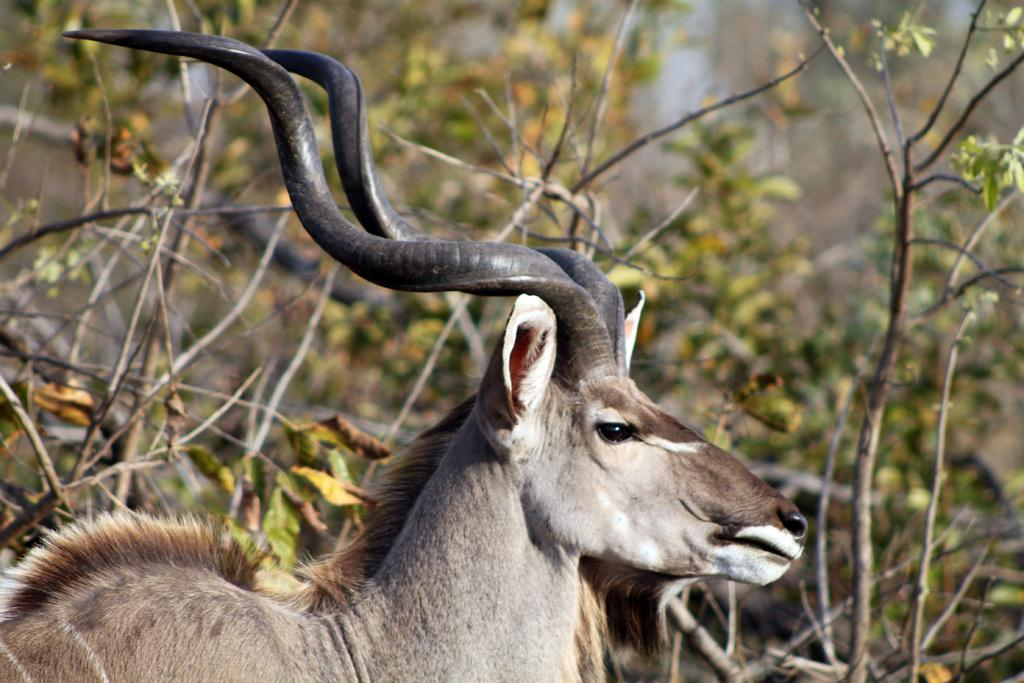What type of animal can be seen in the image? There is an animal in the image, but its specific type cannot be determined from the provided facts. In which direction is the animal looking? The animal is looking to the right side. What can be seen in the background of the image? There are trees and sticks in the background of the image. Is the doctor reading a book while increasing the animal's speed in the image? There is no doctor, book, or speed adjustment present in the image. 